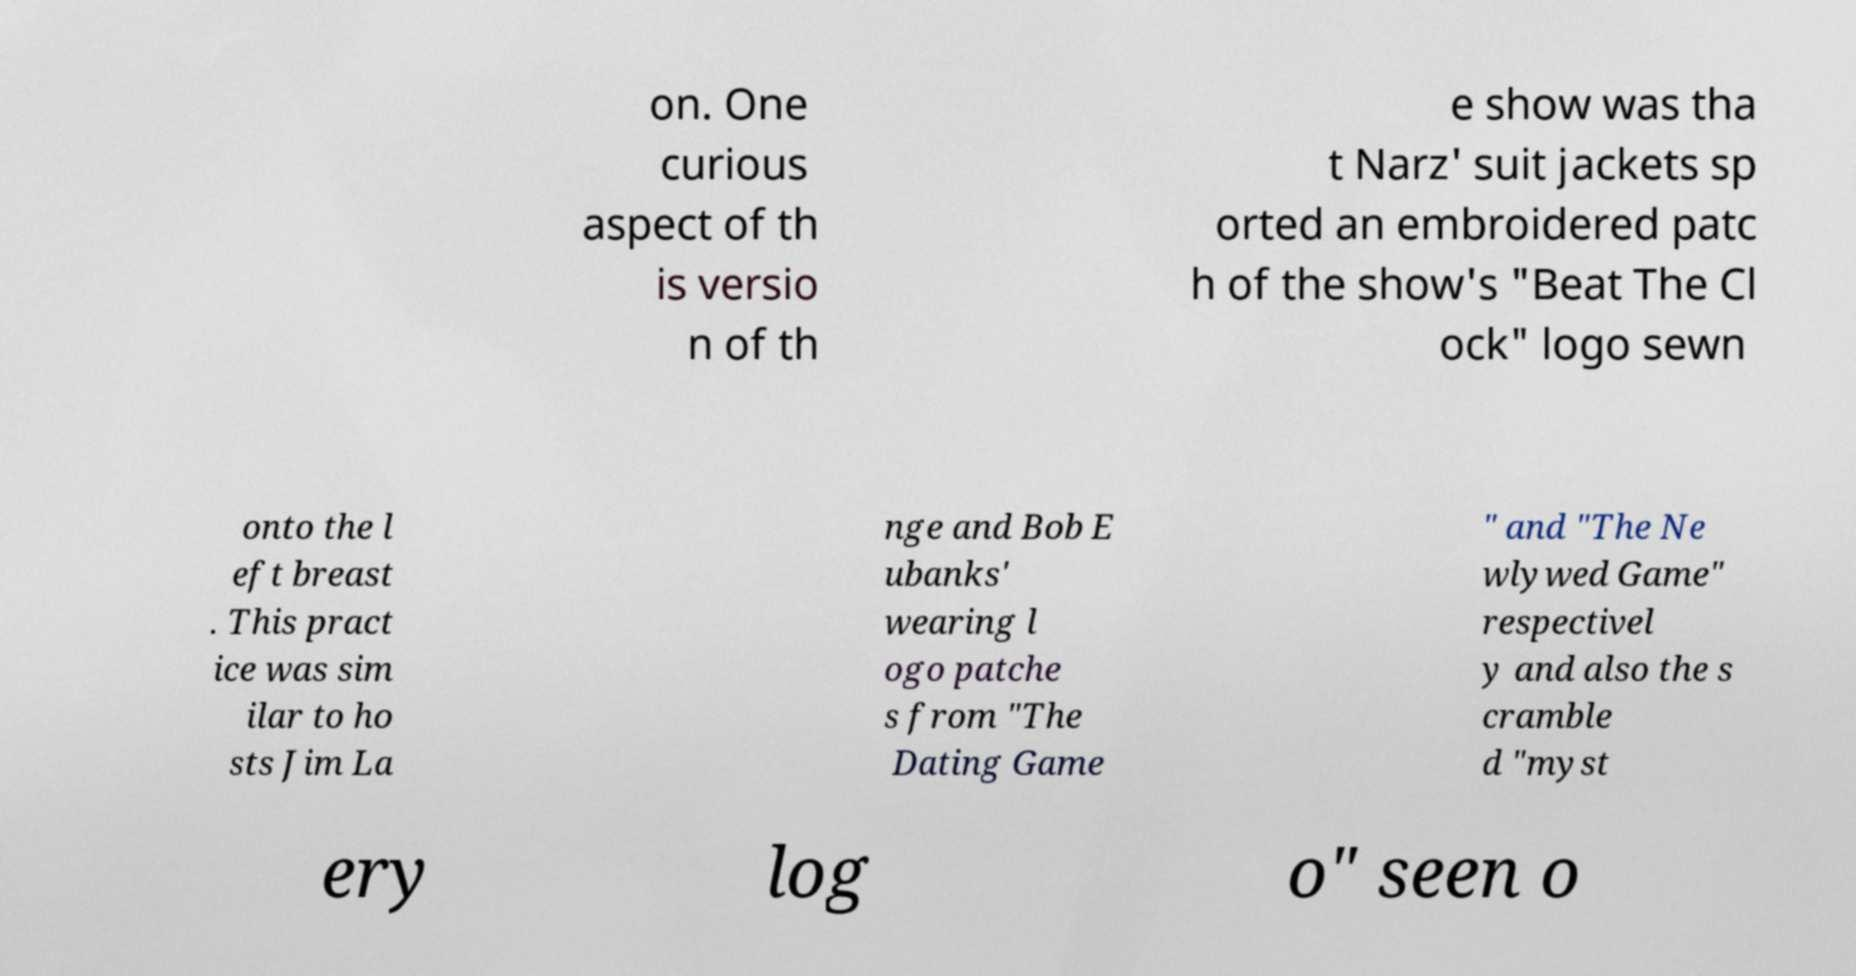For documentation purposes, I need the text within this image transcribed. Could you provide that? on. One curious aspect of th is versio n of th e show was tha t Narz' suit jackets sp orted an embroidered patc h of the show's "Beat The Cl ock" logo sewn onto the l eft breast . This pract ice was sim ilar to ho sts Jim La nge and Bob E ubanks' wearing l ogo patche s from "The Dating Game " and "The Ne wlywed Game" respectivel y and also the s cramble d "myst ery log o" seen o 